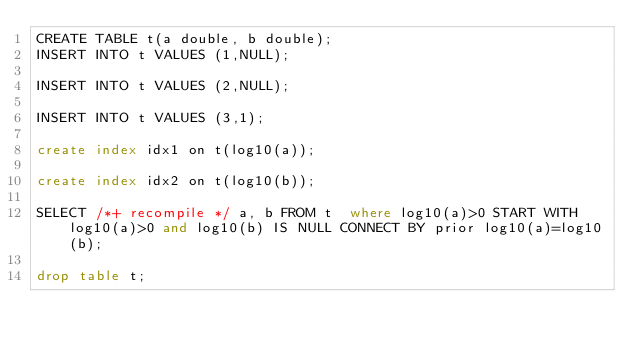Convert code to text. <code><loc_0><loc_0><loc_500><loc_500><_SQL_>CREATE TABLE t(a double, b double);
INSERT INTO t VALUES (1,NULL);

INSERT INTO t VALUES (2,NULL);

INSERT INTO t VALUES (3,1);

create index idx1 on t(log10(a));

create index idx2 on t(log10(b));

SELECT /*+ recompile */ a, b FROM t  where log10(a)>0 START WITH log10(a)>0 and log10(b) IS NULL CONNECT BY prior log10(a)=log10(b);

drop table t;


</code> 